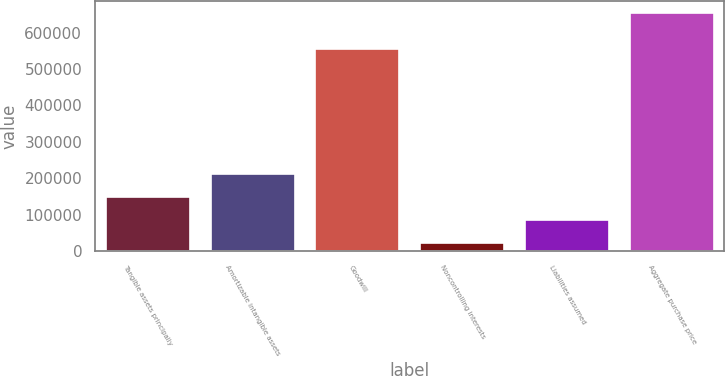Convert chart. <chart><loc_0><loc_0><loc_500><loc_500><bar_chart><fcel>Tangible assets principally<fcel>Amortizable intangible assets<fcel>Goodwill<fcel>Noncontrolling interests<fcel>Liabilities assumed<fcel>Aggregate purchase price<nl><fcel>148453<fcel>211699<fcel>554685<fcel>21962<fcel>85207.7<fcel>654419<nl></chart> 